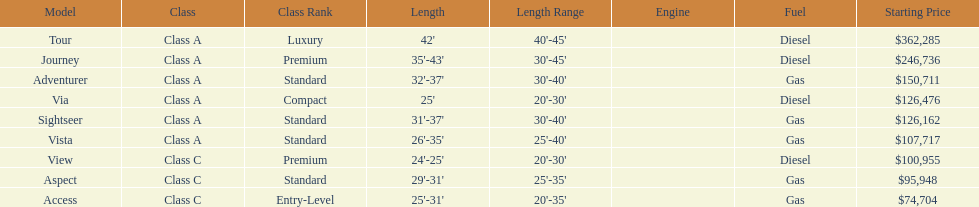Which model had the highest starting price Tour. 